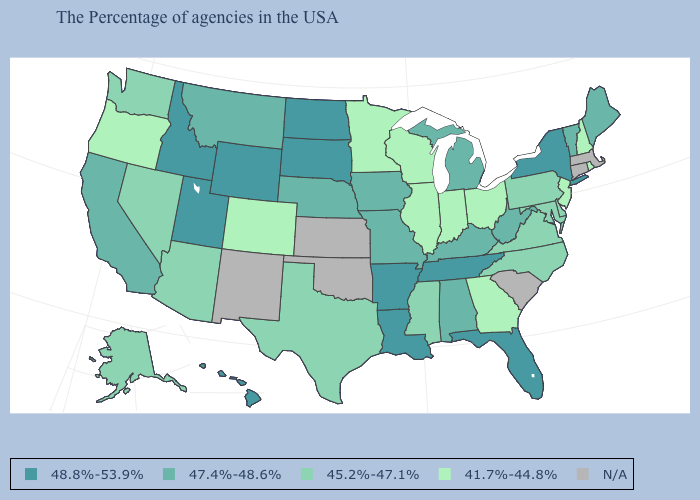What is the value of Rhode Island?
Be succinct. 41.7%-44.8%. How many symbols are there in the legend?
Keep it brief. 5. What is the value of New York?
Concise answer only. 48.8%-53.9%. Which states have the lowest value in the USA?
Quick response, please. Rhode Island, New Hampshire, New Jersey, Ohio, Georgia, Indiana, Wisconsin, Illinois, Minnesota, Colorado, Oregon. What is the highest value in states that border Arkansas?
Give a very brief answer. 48.8%-53.9%. What is the highest value in the South ?
Keep it brief. 48.8%-53.9%. What is the value of Wyoming?
Keep it brief. 48.8%-53.9%. What is the value of Kansas?
Quick response, please. N/A. Is the legend a continuous bar?
Keep it brief. No. Does Rhode Island have the lowest value in the Northeast?
Give a very brief answer. Yes. Name the states that have a value in the range 41.7%-44.8%?
Be succinct. Rhode Island, New Hampshire, New Jersey, Ohio, Georgia, Indiana, Wisconsin, Illinois, Minnesota, Colorado, Oregon. Does New York have the highest value in the Northeast?
Concise answer only. Yes. Does the map have missing data?
Answer briefly. Yes. Among the states that border Minnesota , does North Dakota have the highest value?
Write a very short answer. Yes. 